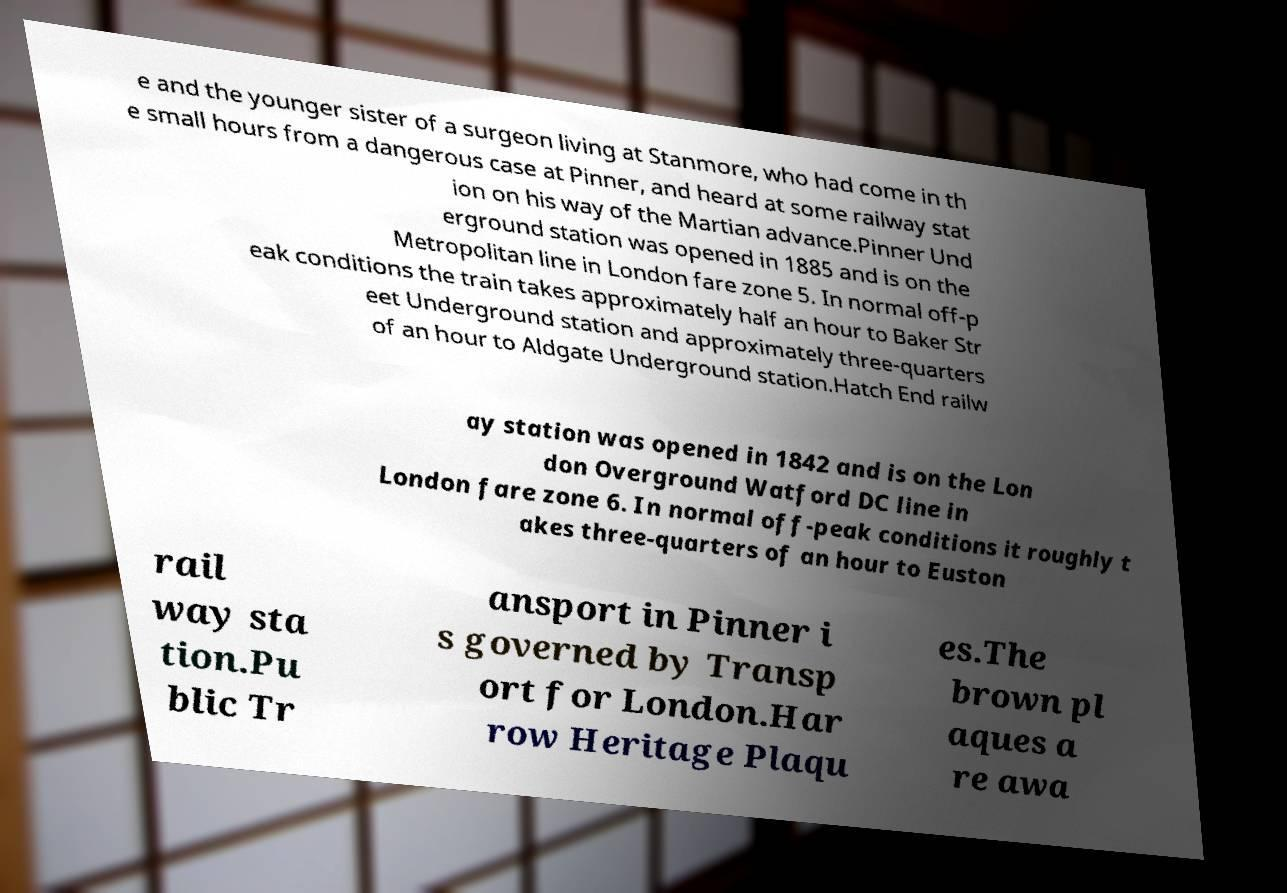Could you extract and type out the text from this image? e and the younger sister of a surgeon living at Stanmore, who had come in th e small hours from a dangerous case at Pinner, and heard at some railway stat ion on his way of the Martian advance.Pinner Und erground station was opened in 1885 and is on the Metropolitan line in London fare zone 5. In normal off-p eak conditions the train takes approximately half an hour to Baker Str eet Underground station and approximately three-quarters of an hour to Aldgate Underground station.Hatch End railw ay station was opened in 1842 and is on the Lon don Overground Watford DC line in London fare zone 6. In normal off-peak conditions it roughly t akes three-quarters of an hour to Euston rail way sta tion.Pu blic Tr ansport in Pinner i s governed by Transp ort for London.Har row Heritage Plaqu es.The brown pl aques a re awa 